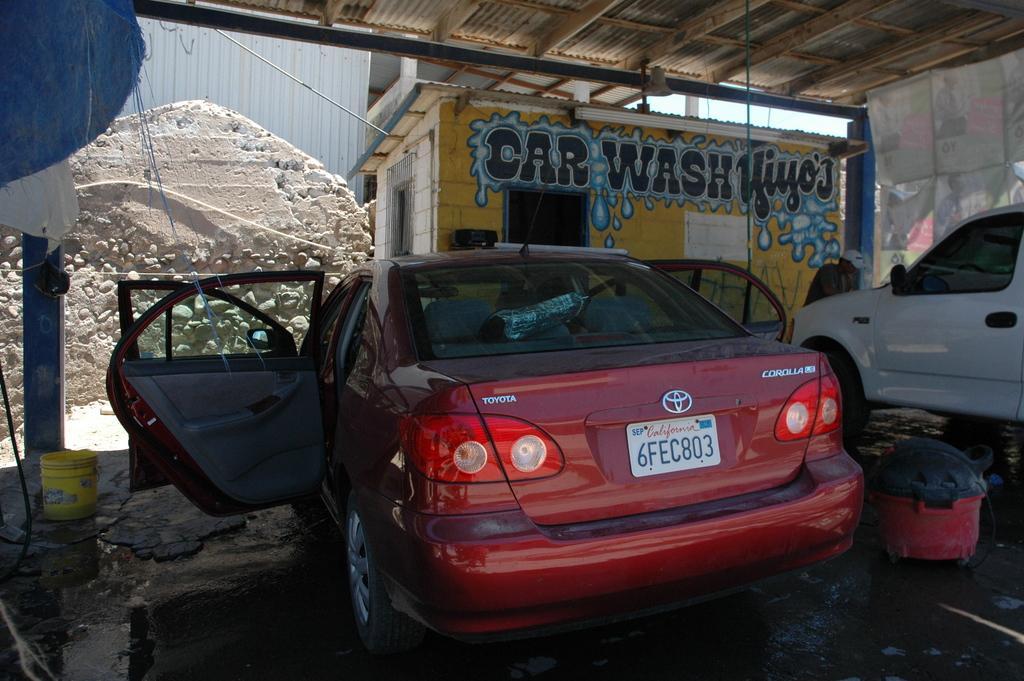Describe this image in one or two sentences. In this image we can see a car with its doors opened, beside it there is another car and there are some objects on the ground, in front of it there are buildings with some text written on it. 